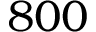Convert formula to latex. <formula><loc_0><loc_0><loc_500><loc_500>8 0 0</formula> 